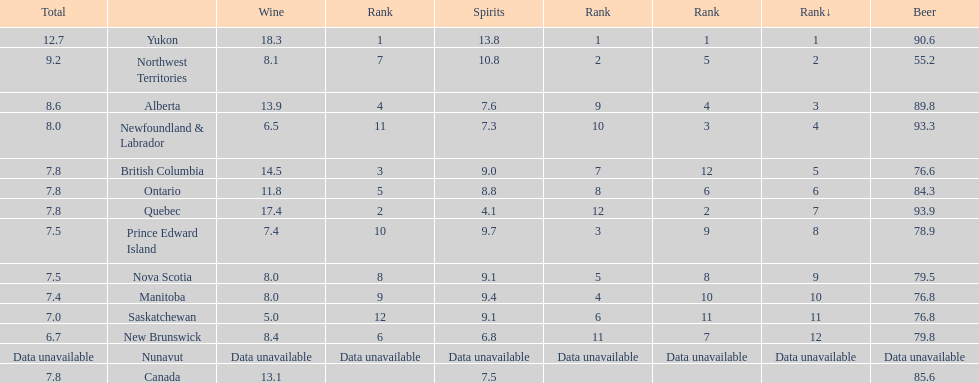What are all the canadian regions? Yukon, Northwest Territories, Alberta, Newfoundland & Labrador, British Columbia, Ontario, Quebec, Prince Edward Island, Nova Scotia, Manitoba, Saskatchewan, New Brunswick, Nunavut, Canada. What was the spirits consumption? 13.8, 10.8, 7.6, 7.3, 9.0, 8.8, 4.1, 9.7, 9.1, 9.4, 9.1, 6.8, Data unavailable, 7.5. What was quebec's spirit consumption? 4.1. 